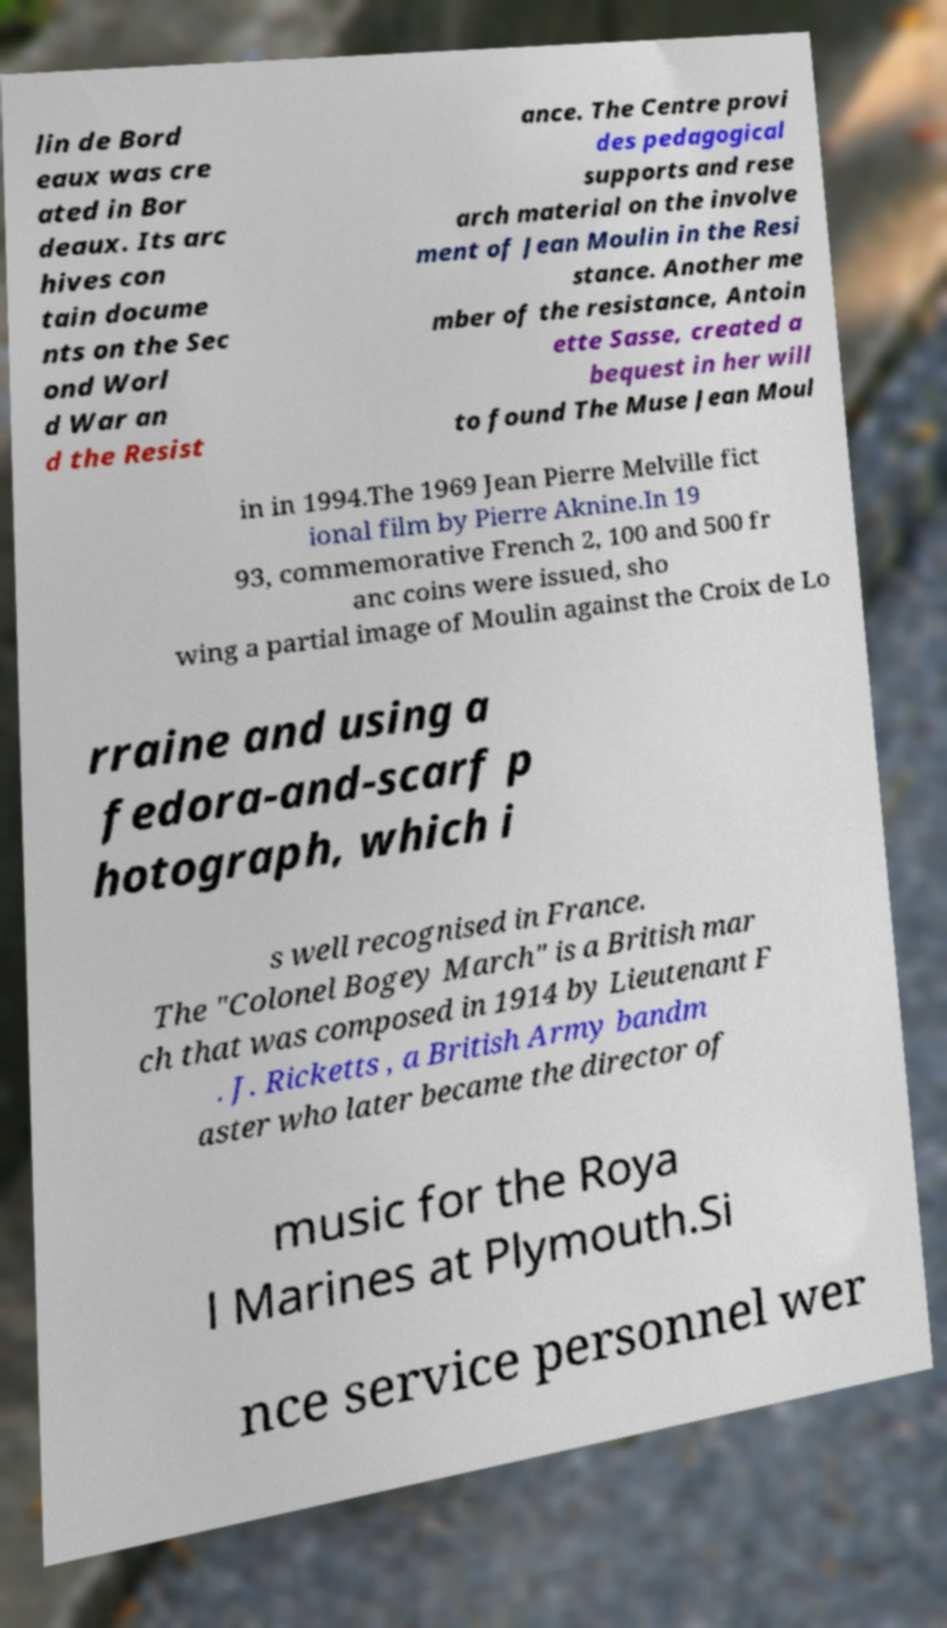Please identify and transcribe the text found in this image. lin de Bord eaux was cre ated in Bor deaux. Its arc hives con tain docume nts on the Sec ond Worl d War an d the Resist ance. The Centre provi des pedagogical supports and rese arch material on the involve ment of Jean Moulin in the Resi stance. Another me mber of the resistance, Antoin ette Sasse, created a bequest in her will to found The Muse Jean Moul in in 1994.The 1969 Jean Pierre Melville fict ional film by Pierre Aknine.In 19 93, commemorative French 2, 100 and 500 fr anc coins were issued, sho wing a partial image of Moulin against the Croix de Lo rraine and using a fedora-and-scarf p hotograph, which i s well recognised in France. The "Colonel Bogey March" is a British mar ch that was composed in 1914 by Lieutenant F . J. Ricketts , a British Army bandm aster who later became the director of music for the Roya l Marines at Plymouth.Si nce service personnel wer 